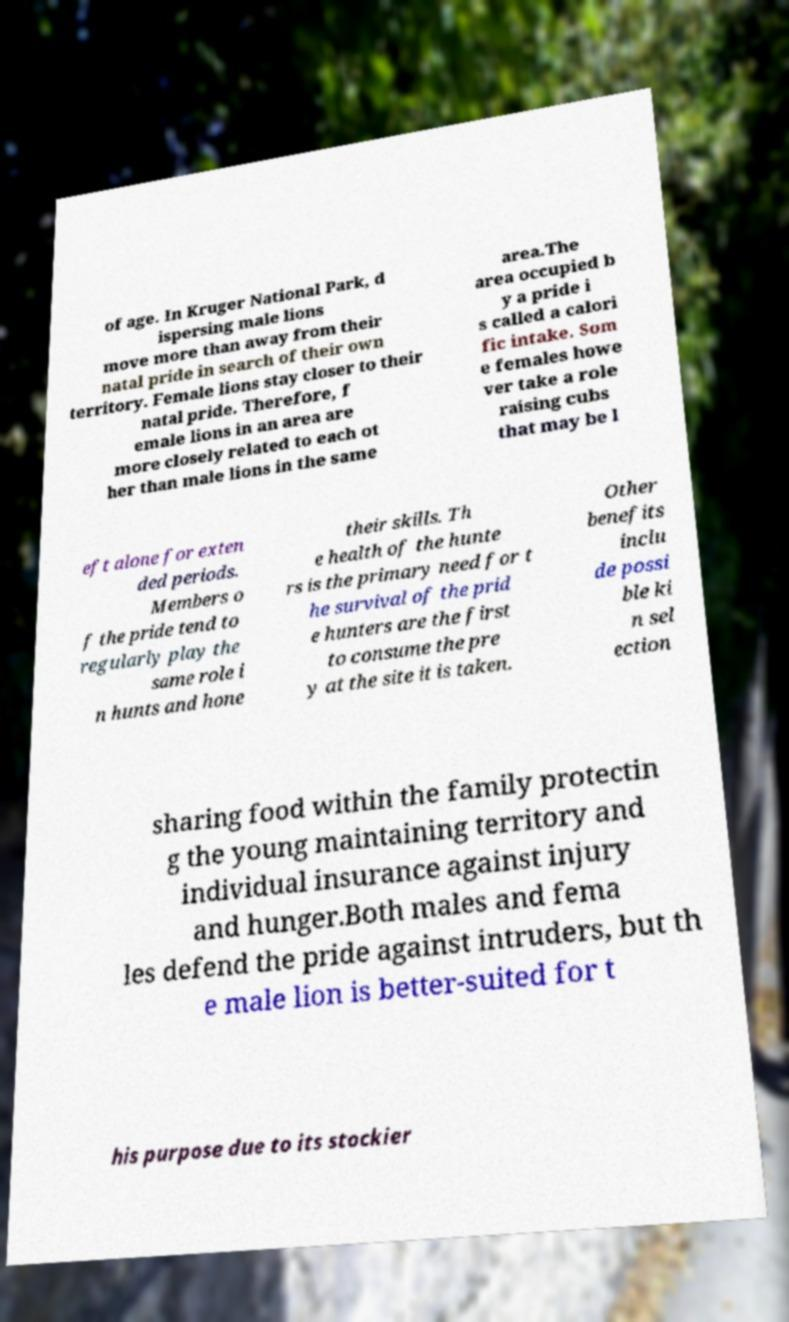Can you read and provide the text displayed in the image?This photo seems to have some interesting text. Can you extract and type it out for me? of age. In Kruger National Park, d ispersing male lions move more than away from their natal pride in search of their own territory. Female lions stay closer to their natal pride. Therefore, f emale lions in an area are more closely related to each ot her than male lions in the same area.The area occupied b y a pride i s called a calori fic intake. Som e females howe ver take a role raising cubs that may be l eft alone for exten ded periods. Members o f the pride tend to regularly play the same role i n hunts and hone their skills. Th e health of the hunte rs is the primary need for t he survival of the prid e hunters are the first to consume the pre y at the site it is taken. Other benefits inclu de possi ble ki n sel ection sharing food within the family protectin g the young maintaining territory and individual insurance against injury and hunger.Both males and fema les defend the pride against intruders, but th e male lion is better-suited for t his purpose due to its stockier 